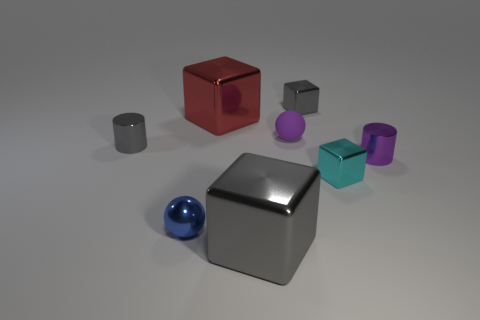Does the gray cylinder have the same material as the small purple ball?
Your answer should be compact. No. How many other objects are there of the same shape as the tiny purple metallic thing?
Make the answer very short. 1. There is a shiny block that is both in front of the small purple matte thing and on the left side of the rubber sphere; how big is it?
Make the answer very short. Large. How many matte things are either big brown cylinders or big red cubes?
Ensure brevity in your answer.  0. Do the big shiny object to the right of the big red metal block and the large thing behind the cyan object have the same shape?
Your response must be concise. Yes. Is there a big blue cylinder that has the same material as the red thing?
Keep it short and to the point. No. What color is the rubber sphere?
Offer a very short reply. Purple. How big is the gray metallic thing in front of the purple shiny object?
Keep it short and to the point. Large. How many cylinders have the same color as the tiny rubber sphere?
Offer a very short reply. 1. There is a large metallic block that is in front of the purple metal cylinder; are there any gray objects that are behind it?
Provide a succinct answer. Yes. 